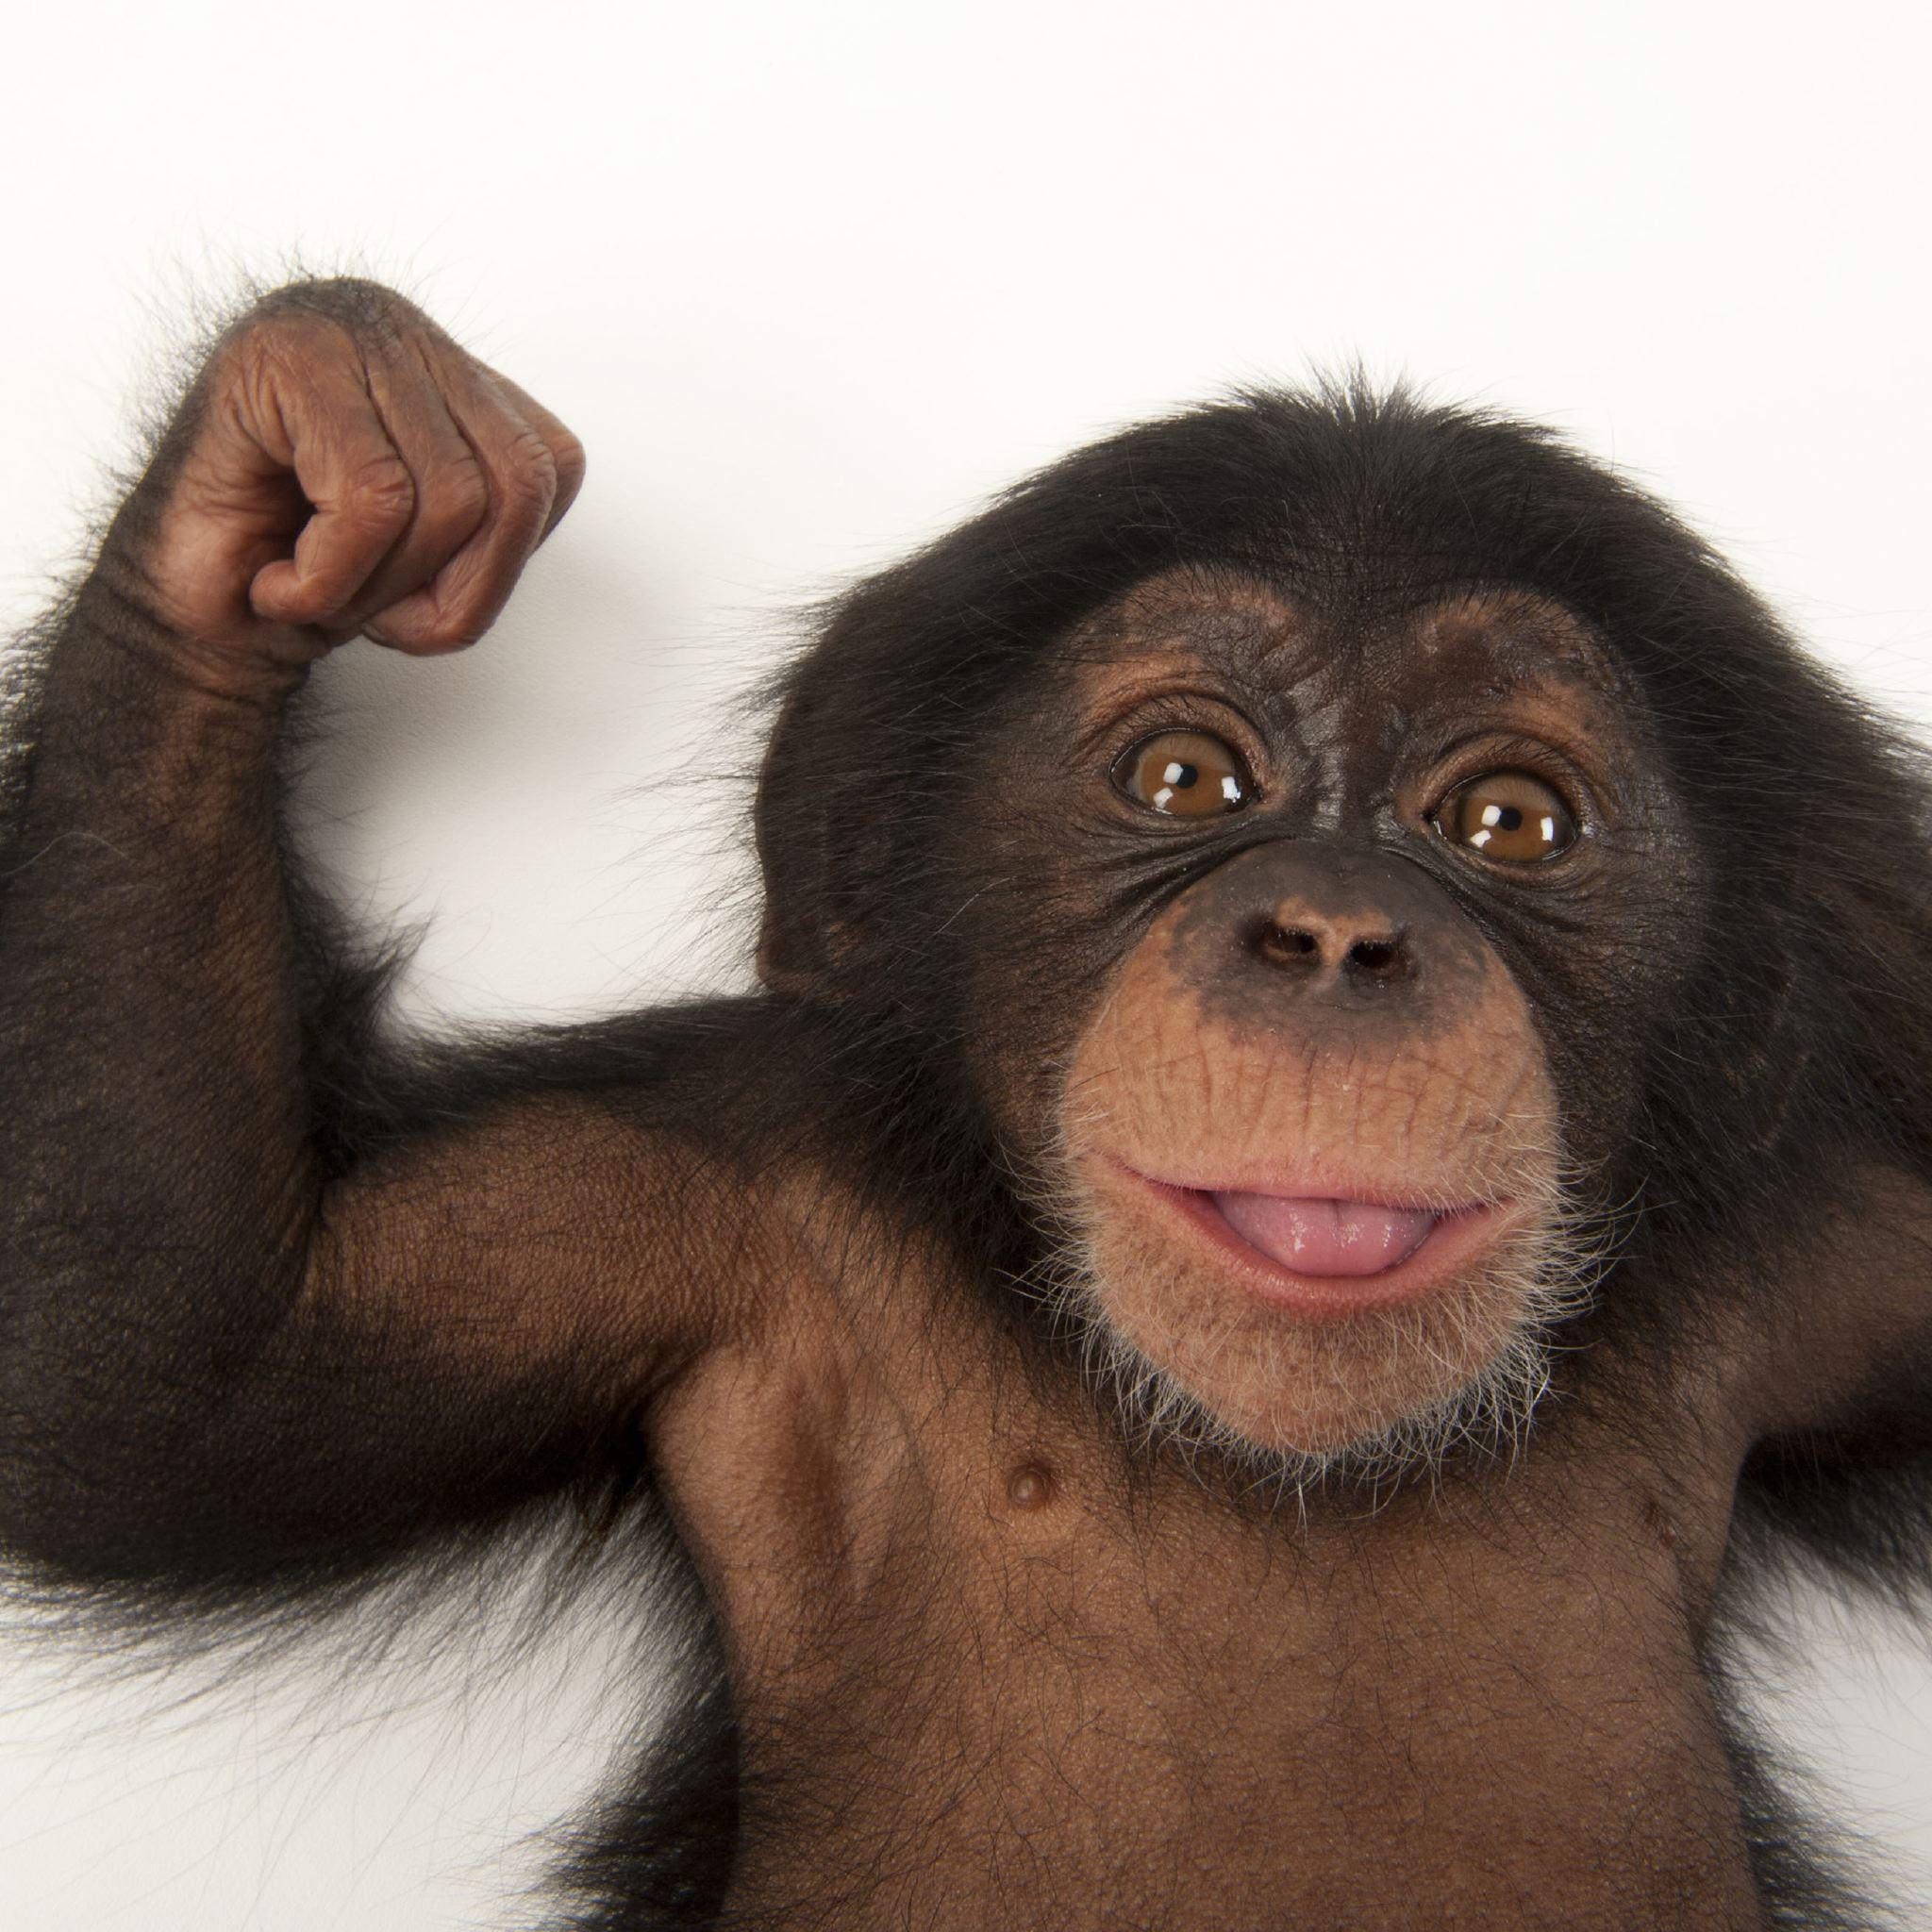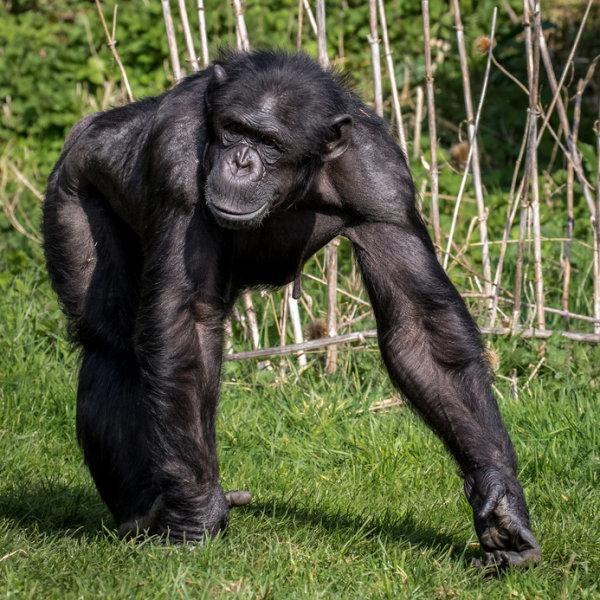The first image is the image on the left, the second image is the image on the right. For the images shown, is this caption "There is exactly one animal in the image on the right." true? Answer yes or no. Yes. The first image is the image on the left, the second image is the image on the right. For the images shown, is this caption "One image shows two chimpanzees sitting in the grass together." true? Answer yes or no. No. 